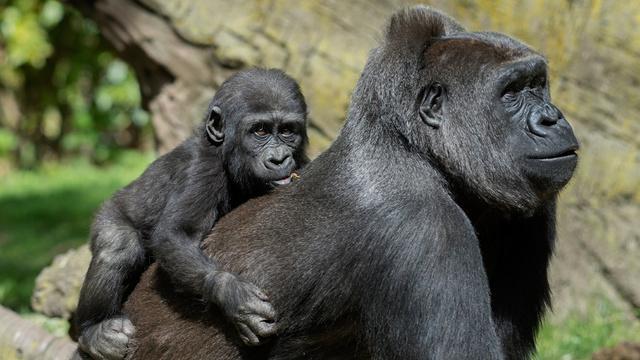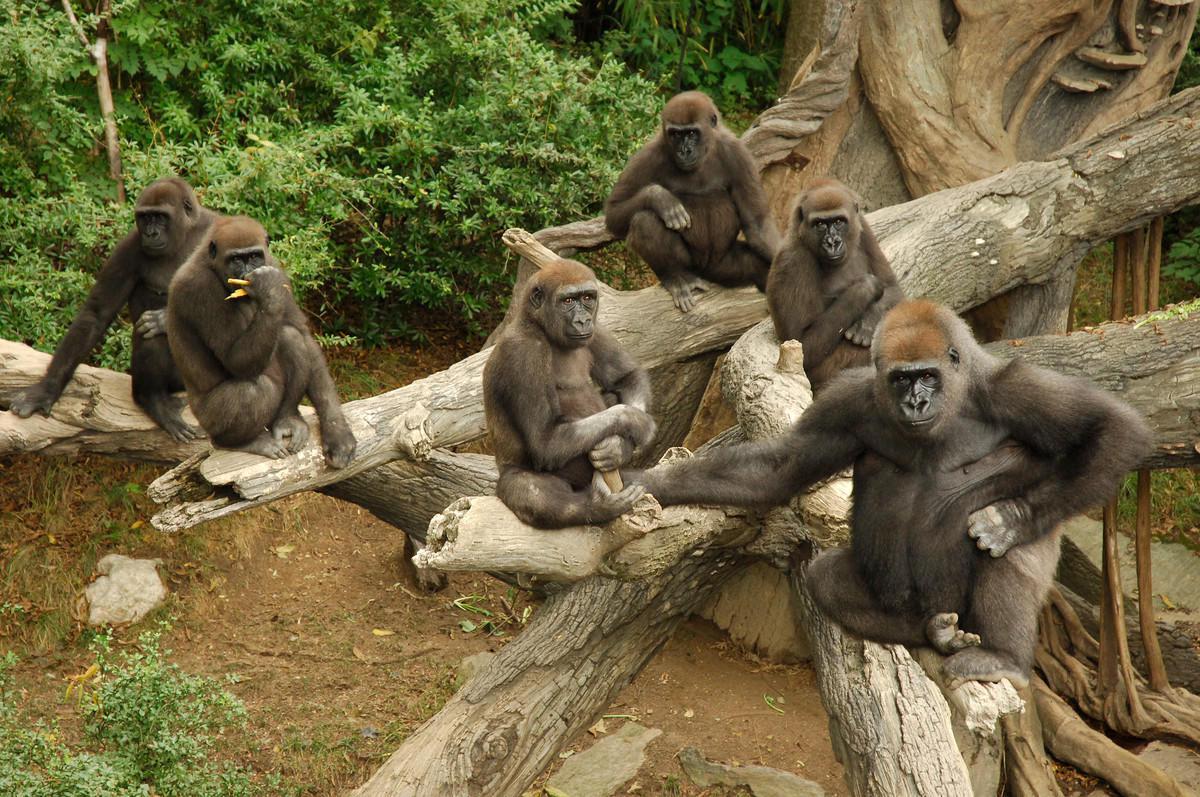The first image is the image on the left, the second image is the image on the right. For the images displayed, is the sentence "There are parts of at least four gorillas visible." factually correct? Answer yes or no. Yes. The first image is the image on the left, the second image is the image on the right. Considering the images on both sides, is "An image shows a gorilla sitting and holding a baby animal to its chest." valid? Answer yes or no. No. 